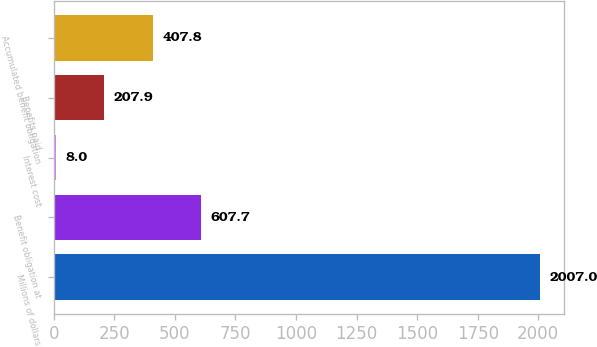<chart> <loc_0><loc_0><loc_500><loc_500><bar_chart><fcel>Millions of dollars<fcel>Benefit obligation at<fcel>Interest cost<fcel>Benefits paid<fcel>Accumulated benefit obligation<nl><fcel>2007<fcel>607.7<fcel>8<fcel>207.9<fcel>407.8<nl></chart> 